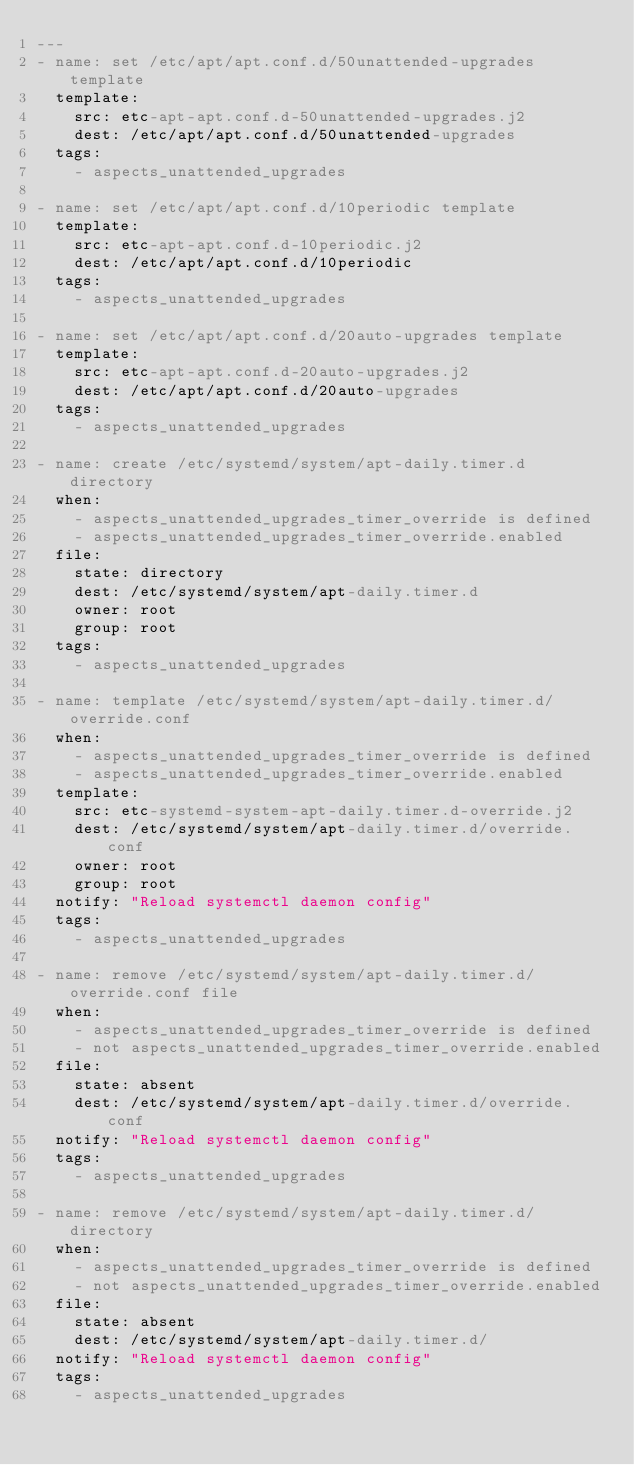<code> <loc_0><loc_0><loc_500><loc_500><_YAML_>---
- name: set /etc/apt/apt.conf.d/50unattended-upgrades template
  template:
    src: etc-apt-apt.conf.d-50unattended-upgrades.j2
    dest: /etc/apt/apt.conf.d/50unattended-upgrades
  tags:
    - aspects_unattended_upgrades

- name: set /etc/apt/apt.conf.d/10periodic template
  template:
    src: etc-apt-apt.conf.d-10periodic.j2
    dest: /etc/apt/apt.conf.d/10periodic
  tags:
    - aspects_unattended_upgrades

- name: set /etc/apt/apt.conf.d/20auto-upgrades template
  template:
    src: etc-apt-apt.conf.d-20auto-upgrades.j2
    dest: /etc/apt/apt.conf.d/20auto-upgrades
  tags:
    - aspects_unattended_upgrades

- name: create /etc/systemd/system/apt-daily.timer.d directory
  when:
    - aspects_unattended_upgrades_timer_override is defined
    - aspects_unattended_upgrades_timer_override.enabled
  file:
    state: directory
    dest: /etc/systemd/system/apt-daily.timer.d
    owner: root
    group: root
  tags:
    - aspects_unattended_upgrades

- name: template /etc/systemd/system/apt-daily.timer.d/override.conf
  when:
    - aspects_unattended_upgrades_timer_override is defined
    - aspects_unattended_upgrades_timer_override.enabled
  template:
    src: etc-systemd-system-apt-daily.timer.d-override.j2
    dest: /etc/systemd/system/apt-daily.timer.d/override.conf
    owner: root
    group: root
  notify: "Reload systemctl daemon config"
  tags:
    - aspects_unattended_upgrades

- name: remove /etc/systemd/system/apt-daily.timer.d/override.conf file
  when:
    - aspects_unattended_upgrades_timer_override is defined
    - not aspects_unattended_upgrades_timer_override.enabled
  file:
    state: absent
    dest: /etc/systemd/system/apt-daily.timer.d/override.conf
  notify: "Reload systemctl daemon config"
  tags:
    - aspects_unattended_upgrades

- name: remove /etc/systemd/system/apt-daily.timer.d/directory
  when:
    - aspects_unattended_upgrades_timer_override is defined
    - not aspects_unattended_upgrades_timer_override.enabled
  file:
    state: absent
    dest: /etc/systemd/system/apt-daily.timer.d/
  notify: "Reload systemctl daemon config"
  tags:
    - aspects_unattended_upgrades</code> 